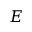Convert formula to latex. <formula><loc_0><loc_0><loc_500><loc_500>E</formula> 